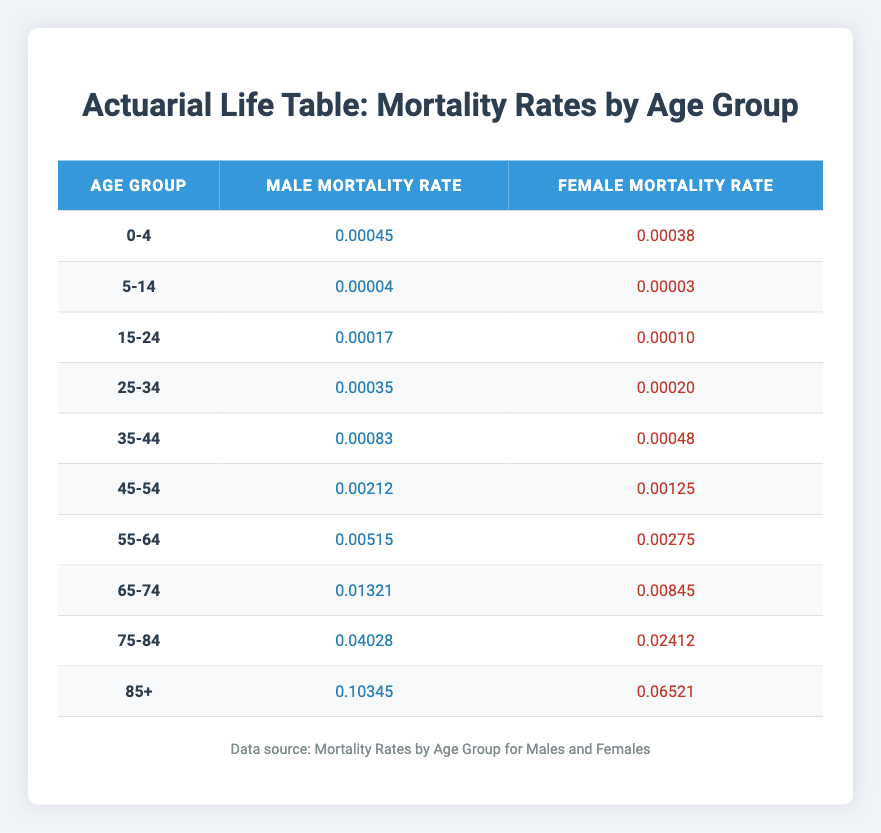What is the male mortality rate for the age group 55-64? According to the table, the male mortality rate for the age group 55-64 is directly listed, so we can find it easily. The corresponding value in the table is 0.00515.
Answer: 0.00515 What is the female mortality rate for the age group 75-84? The table shows the female mortality rate for the age group 75-84, which is found in the specific row. It is 0.02412 in the table.
Answer: 0.02412 Are mortality rates for females higher than for males in the age group 15-24? To answer this, we compare the values in the table for both sexes in the age group 15-24. The male mortality rate is 0.00017, and the female mortality rate is 0.00010. Since 0.00010 is less than 0.00017, the statement is false.
Answer: No What is the difference in mortality rates between males and females for the 45-54 age group? We first identify the mortality rates for both genders in the 45-54 age group from the table: male rate is 0.00212, and female rate is 0.00125. To find the difference, we subtract the female rate from the male rate: 0.00212 - 0.00125 = 0.00087.
Answer: 0.00087 What is the average male mortality rate for the age groups 0-4 and 85+? To find the average, we first get the male mortality rates from the respective age groups: for 0-4 it is 0.00045, and for 85+ it is 0.10345. We then add these values: 0.00045 + 0.10345 = 0.10390. Finally, we divide by the number of age groups (2) to find the average: 0.10390 / 2 = 0.05195.
Answer: 0.05195 Is the male mortality rate in the age group 65-74 greater than 0.01? We examine the male mortality rate for the age group 65-74 in the table, which is 0.01321. Since 0.01321 is greater than 0.01, the statement is true.
Answer: Yes What is the sum of the female mortality rates for the age groups 5-14 and 15-24? We locate the female mortality rates for the age groups 5-14 (0.00003) and 15-24 (0.00010) in the table. Adding these rates gives: 0.00003 + 0.00010 = 0.00013.
Answer: 0.00013 How does the male mortality rate for the age group 35-44 compare to that for 25-34? The table lists the male mortality rate for 35-44 as 0.00083 and for 25-34 as 0.00035. Comparing them, we find that 0.00083 is greater than 0.00035, meaning the male mortality rate for 35-44 is higher.
Answer: Yes What is the maximum female mortality rate recorded in the table? To find the maximum, we examine all the female mortality rates listed in the table. The highest value is 0.06521 for the age group 85+.
Answer: 0.06521 